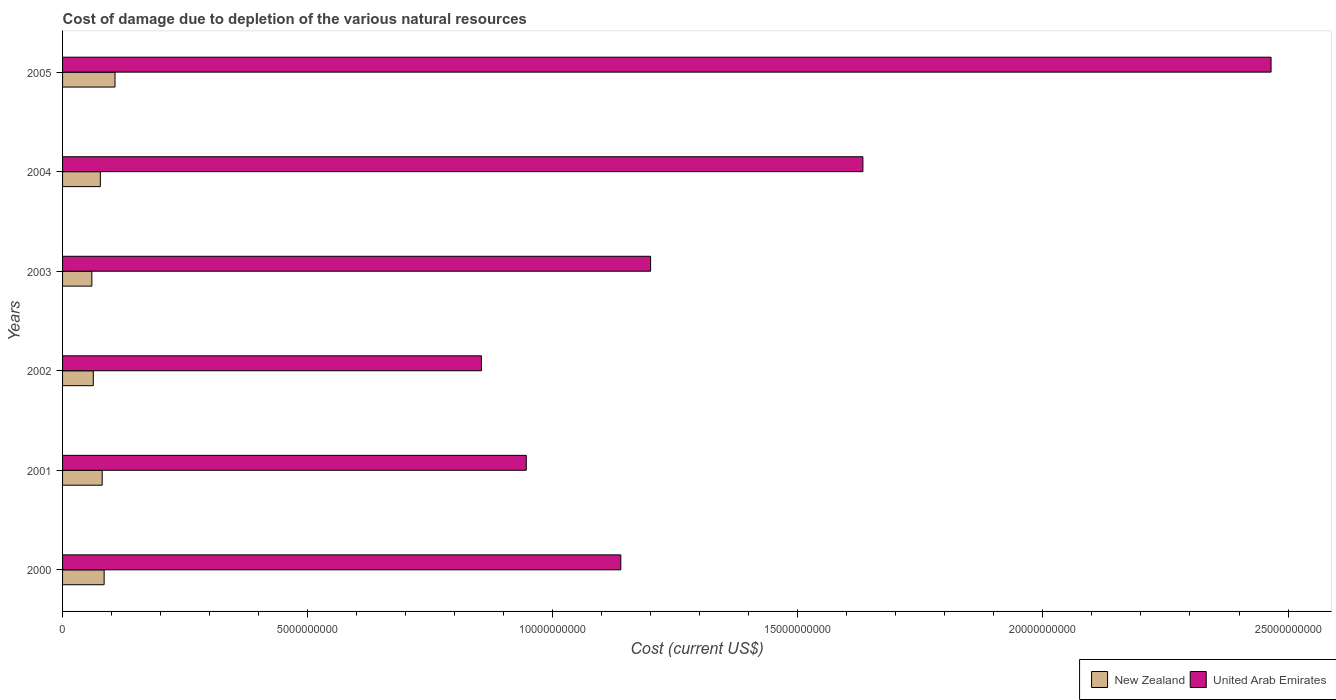Are the number of bars on each tick of the Y-axis equal?
Offer a terse response. Yes. How many bars are there on the 1st tick from the top?
Give a very brief answer. 2. How many bars are there on the 6th tick from the bottom?
Make the answer very short. 2. What is the cost of damage caused due to the depletion of various natural resources in New Zealand in 2003?
Offer a terse response. 5.98e+08. Across all years, what is the maximum cost of damage caused due to the depletion of various natural resources in New Zealand?
Provide a succinct answer. 1.07e+09. Across all years, what is the minimum cost of damage caused due to the depletion of various natural resources in United Arab Emirates?
Offer a terse response. 8.54e+09. What is the total cost of damage caused due to the depletion of various natural resources in United Arab Emirates in the graph?
Ensure brevity in your answer.  8.24e+1. What is the difference between the cost of damage caused due to the depletion of various natural resources in New Zealand in 2000 and that in 2001?
Keep it short and to the point. 3.98e+07. What is the difference between the cost of damage caused due to the depletion of various natural resources in United Arab Emirates in 2005 and the cost of damage caused due to the depletion of various natural resources in New Zealand in 2003?
Provide a short and direct response. 2.41e+1. What is the average cost of damage caused due to the depletion of various natural resources in United Arab Emirates per year?
Give a very brief answer. 1.37e+1. In the year 2005, what is the difference between the cost of damage caused due to the depletion of various natural resources in United Arab Emirates and cost of damage caused due to the depletion of various natural resources in New Zealand?
Give a very brief answer. 2.36e+1. What is the ratio of the cost of damage caused due to the depletion of various natural resources in New Zealand in 2003 to that in 2004?
Keep it short and to the point. 0.78. What is the difference between the highest and the second highest cost of damage caused due to the depletion of various natural resources in United Arab Emirates?
Ensure brevity in your answer.  8.33e+09. What is the difference between the highest and the lowest cost of damage caused due to the depletion of various natural resources in New Zealand?
Your answer should be very brief. 4.72e+08. In how many years, is the cost of damage caused due to the depletion of various natural resources in New Zealand greater than the average cost of damage caused due to the depletion of various natural resources in New Zealand taken over all years?
Provide a short and direct response. 3. What does the 2nd bar from the top in 2003 represents?
Your answer should be compact. New Zealand. What does the 2nd bar from the bottom in 2001 represents?
Ensure brevity in your answer.  United Arab Emirates. How many years are there in the graph?
Your response must be concise. 6. What is the difference between two consecutive major ticks on the X-axis?
Your answer should be compact. 5.00e+09. Are the values on the major ticks of X-axis written in scientific E-notation?
Provide a short and direct response. No. Does the graph contain any zero values?
Give a very brief answer. No. Where does the legend appear in the graph?
Make the answer very short. Bottom right. How are the legend labels stacked?
Your response must be concise. Horizontal. What is the title of the graph?
Offer a very short reply. Cost of damage due to depletion of the various natural resources. What is the label or title of the X-axis?
Your response must be concise. Cost (current US$). What is the label or title of the Y-axis?
Ensure brevity in your answer.  Years. What is the Cost (current US$) of New Zealand in 2000?
Make the answer very short. 8.48e+08. What is the Cost (current US$) of United Arab Emirates in 2000?
Your answer should be very brief. 1.14e+1. What is the Cost (current US$) of New Zealand in 2001?
Make the answer very short. 8.08e+08. What is the Cost (current US$) in United Arab Emirates in 2001?
Provide a short and direct response. 9.46e+09. What is the Cost (current US$) in New Zealand in 2002?
Provide a succinct answer. 6.27e+08. What is the Cost (current US$) in United Arab Emirates in 2002?
Offer a very short reply. 8.54e+09. What is the Cost (current US$) in New Zealand in 2003?
Provide a succinct answer. 5.98e+08. What is the Cost (current US$) of United Arab Emirates in 2003?
Your answer should be very brief. 1.20e+1. What is the Cost (current US$) in New Zealand in 2004?
Offer a very short reply. 7.71e+08. What is the Cost (current US$) of United Arab Emirates in 2004?
Ensure brevity in your answer.  1.63e+1. What is the Cost (current US$) of New Zealand in 2005?
Ensure brevity in your answer.  1.07e+09. What is the Cost (current US$) of United Arab Emirates in 2005?
Your response must be concise. 2.47e+1. Across all years, what is the maximum Cost (current US$) of New Zealand?
Your answer should be very brief. 1.07e+09. Across all years, what is the maximum Cost (current US$) in United Arab Emirates?
Offer a terse response. 2.47e+1. Across all years, what is the minimum Cost (current US$) of New Zealand?
Your answer should be very brief. 5.98e+08. Across all years, what is the minimum Cost (current US$) of United Arab Emirates?
Your answer should be compact. 8.54e+09. What is the total Cost (current US$) of New Zealand in the graph?
Your response must be concise. 4.72e+09. What is the total Cost (current US$) of United Arab Emirates in the graph?
Offer a very short reply. 8.24e+1. What is the difference between the Cost (current US$) of New Zealand in 2000 and that in 2001?
Keep it short and to the point. 3.98e+07. What is the difference between the Cost (current US$) of United Arab Emirates in 2000 and that in 2001?
Offer a terse response. 1.93e+09. What is the difference between the Cost (current US$) in New Zealand in 2000 and that in 2002?
Your answer should be compact. 2.21e+08. What is the difference between the Cost (current US$) in United Arab Emirates in 2000 and that in 2002?
Offer a very short reply. 2.84e+09. What is the difference between the Cost (current US$) of New Zealand in 2000 and that in 2003?
Make the answer very short. 2.51e+08. What is the difference between the Cost (current US$) in United Arab Emirates in 2000 and that in 2003?
Your response must be concise. -6.07e+08. What is the difference between the Cost (current US$) in New Zealand in 2000 and that in 2004?
Keep it short and to the point. 7.73e+07. What is the difference between the Cost (current US$) of United Arab Emirates in 2000 and that in 2004?
Provide a succinct answer. -4.94e+09. What is the difference between the Cost (current US$) in New Zealand in 2000 and that in 2005?
Your answer should be very brief. -2.22e+08. What is the difference between the Cost (current US$) in United Arab Emirates in 2000 and that in 2005?
Your response must be concise. -1.33e+1. What is the difference between the Cost (current US$) of New Zealand in 2001 and that in 2002?
Make the answer very short. 1.81e+08. What is the difference between the Cost (current US$) of United Arab Emirates in 2001 and that in 2002?
Your answer should be compact. 9.15e+08. What is the difference between the Cost (current US$) in New Zealand in 2001 and that in 2003?
Offer a terse response. 2.11e+08. What is the difference between the Cost (current US$) in United Arab Emirates in 2001 and that in 2003?
Your response must be concise. -2.54e+09. What is the difference between the Cost (current US$) of New Zealand in 2001 and that in 2004?
Your answer should be compact. 3.76e+07. What is the difference between the Cost (current US$) of United Arab Emirates in 2001 and that in 2004?
Ensure brevity in your answer.  -6.87e+09. What is the difference between the Cost (current US$) in New Zealand in 2001 and that in 2005?
Offer a very short reply. -2.62e+08. What is the difference between the Cost (current US$) in United Arab Emirates in 2001 and that in 2005?
Provide a short and direct response. -1.52e+1. What is the difference between the Cost (current US$) in New Zealand in 2002 and that in 2003?
Your answer should be compact. 2.94e+07. What is the difference between the Cost (current US$) of United Arab Emirates in 2002 and that in 2003?
Your answer should be very brief. -3.45e+09. What is the difference between the Cost (current US$) in New Zealand in 2002 and that in 2004?
Keep it short and to the point. -1.44e+08. What is the difference between the Cost (current US$) in United Arab Emirates in 2002 and that in 2004?
Give a very brief answer. -7.78e+09. What is the difference between the Cost (current US$) in New Zealand in 2002 and that in 2005?
Give a very brief answer. -4.43e+08. What is the difference between the Cost (current US$) of United Arab Emirates in 2002 and that in 2005?
Make the answer very short. -1.61e+1. What is the difference between the Cost (current US$) of New Zealand in 2003 and that in 2004?
Offer a very short reply. -1.73e+08. What is the difference between the Cost (current US$) of United Arab Emirates in 2003 and that in 2004?
Ensure brevity in your answer.  -4.33e+09. What is the difference between the Cost (current US$) in New Zealand in 2003 and that in 2005?
Your response must be concise. -4.72e+08. What is the difference between the Cost (current US$) in United Arab Emirates in 2003 and that in 2005?
Make the answer very short. -1.27e+1. What is the difference between the Cost (current US$) in New Zealand in 2004 and that in 2005?
Your answer should be compact. -2.99e+08. What is the difference between the Cost (current US$) of United Arab Emirates in 2004 and that in 2005?
Give a very brief answer. -8.33e+09. What is the difference between the Cost (current US$) of New Zealand in 2000 and the Cost (current US$) of United Arab Emirates in 2001?
Provide a short and direct response. -8.61e+09. What is the difference between the Cost (current US$) of New Zealand in 2000 and the Cost (current US$) of United Arab Emirates in 2002?
Your answer should be compact. -7.70e+09. What is the difference between the Cost (current US$) in New Zealand in 2000 and the Cost (current US$) in United Arab Emirates in 2003?
Make the answer very short. -1.11e+1. What is the difference between the Cost (current US$) of New Zealand in 2000 and the Cost (current US$) of United Arab Emirates in 2004?
Offer a terse response. -1.55e+1. What is the difference between the Cost (current US$) in New Zealand in 2000 and the Cost (current US$) in United Arab Emirates in 2005?
Make the answer very short. -2.38e+1. What is the difference between the Cost (current US$) in New Zealand in 2001 and the Cost (current US$) in United Arab Emirates in 2002?
Give a very brief answer. -7.74e+09. What is the difference between the Cost (current US$) in New Zealand in 2001 and the Cost (current US$) in United Arab Emirates in 2003?
Offer a very short reply. -1.12e+1. What is the difference between the Cost (current US$) of New Zealand in 2001 and the Cost (current US$) of United Arab Emirates in 2004?
Make the answer very short. -1.55e+1. What is the difference between the Cost (current US$) of New Zealand in 2001 and the Cost (current US$) of United Arab Emirates in 2005?
Give a very brief answer. -2.38e+1. What is the difference between the Cost (current US$) of New Zealand in 2002 and the Cost (current US$) of United Arab Emirates in 2003?
Your response must be concise. -1.14e+1. What is the difference between the Cost (current US$) in New Zealand in 2002 and the Cost (current US$) in United Arab Emirates in 2004?
Offer a terse response. -1.57e+1. What is the difference between the Cost (current US$) in New Zealand in 2002 and the Cost (current US$) in United Arab Emirates in 2005?
Your answer should be compact. -2.40e+1. What is the difference between the Cost (current US$) in New Zealand in 2003 and the Cost (current US$) in United Arab Emirates in 2004?
Your answer should be compact. -1.57e+1. What is the difference between the Cost (current US$) in New Zealand in 2003 and the Cost (current US$) in United Arab Emirates in 2005?
Keep it short and to the point. -2.41e+1. What is the difference between the Cost (current US$) in New Zealand in 2004 and the Cost (current US$) in United Arab Emirates in 2005?
Provide a succinct answer. -2.39e+1. What is the average Cost (current US$) of New Zealand per year?
Provide a succinct answer. 7.87e+08. What is the average Cost (current US$) of United Arab Emirates per year?
Your answer should be compact. 1.37e+1. In the year 2000, what is the difference between the Cost (current US$) in New Zealand and Cost (current US$) in United Arab Emirates?
Your answer should be very brief. -1.05e+1. In the year 2001, what is the difference between the Cost (current US$) of New Zealand and Cost (current US$) of United Arab Emirates?
Your answer should be compact. -8.65e+09. In the year 2002, what is the difference between the Cost (current US$) in New Zealand and Cost (current US$) in United Arab Emirates?
Offer a very short reply. -7.92e+09. In the year 2003, what is the difference between the Cost (current US$) of New Zealand and Cost (current US$) of United Arab Emirates?
Provide a short and direct response. -1.14e+1. In the year 2004, what is the difference between the Cost (current US$) of New Zealand and Cost (current US$) of United Arab Emirates?
Keep it short and to the point. -1.56e+1. In the year 2005, what is the difference between the Cost (current US$) in New Zealand and Cost (current US$) in United Arab Emirates?
Your answer should be very brief. -2.36e+1. What is the ratio of the Cost (current US$) in New Zealand in 2000 to that in 2001?
Keep it short and to the point. 1.05. What is the ratio of the Cost (current US$) in United Arab Emirates in 2000 to that in 2001?
Your answer should be compact. 1.2. What is the ratio of the Cost (current US$) in New Zealand in 2000 to that in 2002?
Your answer should be compact. 1.35. What is the ratio of the Cost (current US$) of United Arab Emirates in 2000 to that in 2002?
Give a very brief answer. 1.33. What is the ratio of the Cost (current US$) of New Zealand in 2000 to that in 2003?
Your answer should be compact. 1.42. What is the ratio of the Cost (current US$) in United Arab Emirates in 2000 to that in 2003?
Ensure brevity in your answer.  0.95. What is the ratio of the Cost (current US$) of New Zealand in 2000 to that in 2004?
Offer a very short reply. 1.1. What is the ratio of the Cost (current US$) in United Arab Emirates in 2000 to that in 2004?
Give a very brief answer. 0.7. What is the ratio of the Cost (current US$) in New Zealand in 2000 to that in 2005?
Your answer should be very brief. 0.79. What is the ratio of the Cost (current US$) in United Arab Emirates in 2000 to that in 2005?
Offer a very short reply. 0.46. What is the ratio of the Cost (current US$) of New Zealand in 2001 to that in 2002?
Give a very brief answer. 1.29. What is the ratio of the Cost (current US$) in United Arab Emirates in 2001 to that in 2002?
Provide a short and direct response. 1.11. What is the ratio of the Cost (current US$) of New Zealand in 2001 to that in 2003?
Offer a terse response. 1.35. What is the ratio of the Cost (current US$) of United Arab Emirates in 2001 to that in 2003?
Make the answer very short. 0.79. What is the ratio of the Cost (current US$) of New Zealand in 2001 to that in 2004?
Offer a very short reply. 1.05. What is the ratio of the Cost (current US$) of United Arab Emirates in 2001 to that in 2004?
Keep it short and to the point. 0.58. What is the ratio of the Cost (current US$) of New Zealand in 2001 to that in 2005?
Give a very brief answer. 0.76. What is the ratio of the Cost (current US$) of United Arab Emirates in 2001 to that in 2005?
Provide a succinct answer. 0.38. What is the ratio of the Cost (current US$) in New Zealand in 2002 to that in 2003?
Provide a succinct answer. 1.05. What is the ratio of the Cost (current US$) of United Arab Emirates in 2002 to that in 2003?
Offer a terse response. 0.71. What is the ratio of the Cost (current US$) of New Zealand in 2002 to that in 2004?
Offer a very short reply. 0.81. What is the ratio of the Cost (current US$) of United Arab Emirates in 2002 to that in 2004?
Offer a very short reply. 0.52. What is the ratio of the Cost (current US$) in New Zealand in 2002 to that in 2005?
Provide a short and direct response. 0.59. What is the ratio of the Cost (current US$) in United Arab Emirates in 2002 to that in 2005?
Keep it short and to the point. 0.35. What is the ratio of the Cost (current US$) of New Zealand in 2003 to that in 2004?
Offer a very short reply. 0.78. What is the ratio of the Cost (current US$) of United Arab Emirates in 2003 to that in 2004?
Give a very brief answer. 0.73. What is the ratio of the Cost (current US$) in New Zealand in 2003 to that in 2005?
Your answer should be very brief. 0.56. What is the ratio of the Cost (current US$) of United Arab Emirates in 2003 to that in 2005?
Your answer should be compact. 0.49. What is the ratio of the Cost (current US$) of New Zealand in 2004 to that in 2005?
Your answer should be very brief. 0.72. What is the ratio of the Cost (current US$) of United Arab Emirates in 2004 to that in 2005?
Provide a short and direct response. 0.66. What is the difference between the highest and the second highest Cost (current US$) of New Zealand?
Provide a succinct answer. 2.22e+08. What is the difference between the highest and the second highest Cost (current US$) in United Arab Emirates?
Offer a terse response. 8.33e+09. What is the difference between the highest and the lowest Cost (current US$) of New Zealand?
Give a very brief answer. 4.72e+08. What is the difference between the highest and the lowest Cost (current US$) of United Arab Emirates?
Offer a terse response. 1.61e+1. 